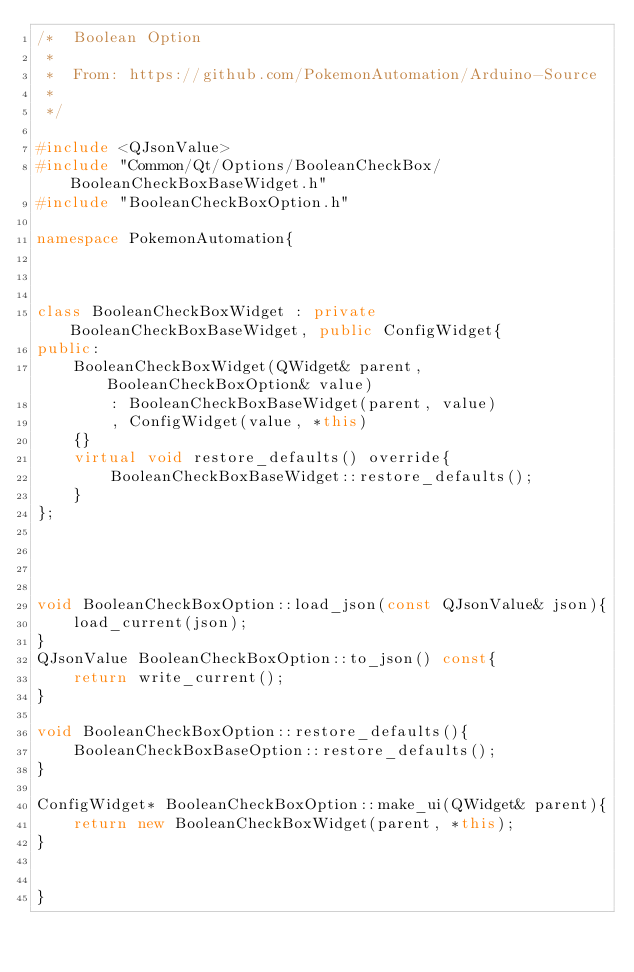Convert code to text. <code><loc_0><loc_0><loc_500><loc_500><_C++_>/*  Boolean Option
 *
 *  From: https://github.com/PokemonAutomation/Arduino-Source
 *
 */

#include <QJsonValue>
#include "Common/Qt/Options/BooleanCheckBox/BooleanCheckBoxBaseWidget.h"
#include "BooleanCheckBoxOption.h"

namespace PokemonAutomation{



class BooleanCheckBoxWidget : private BooleanCheckBoxBaseWidget, public ConfigWidget{
public:
    BooleanCheckBoxWidget(QWidget& parent, BooleanCheckBoxOption& value)
        : BooleanCheckBoxBaseWidget(parent, value)
        , ConfigWidget(value, *this)
    {}
    virtual void restore_defaults() override{
        BooleanCheckBoxBaseWidget::restore_defaults();
    }
};




void BooleanCheckBoxOption::load_json(const QJsonValue& json){
    load_current(json);
}
QJsonValue BooleanCheckBoxOption::to_json() const{
    return write_current();
}

void BooleanCheckBoxOption::restore_defaults(){
    BooleanCheckBoxBaseOption::restore_defaults();
}

ConfigWidget* BooleanCheckBoxOption::make_ui(QWidget& parent){
    return new BooleanCheckBoxWidget(parent, *this);
}


}
</code> 